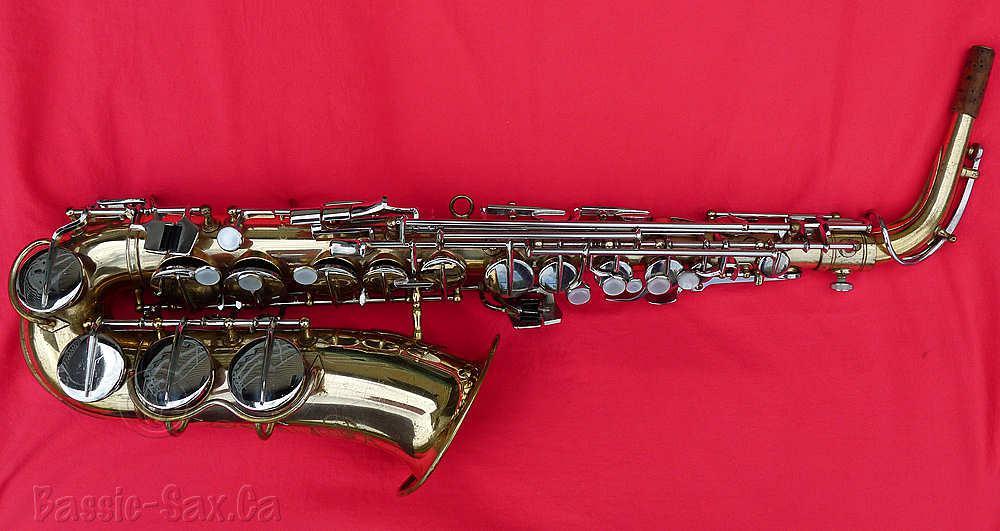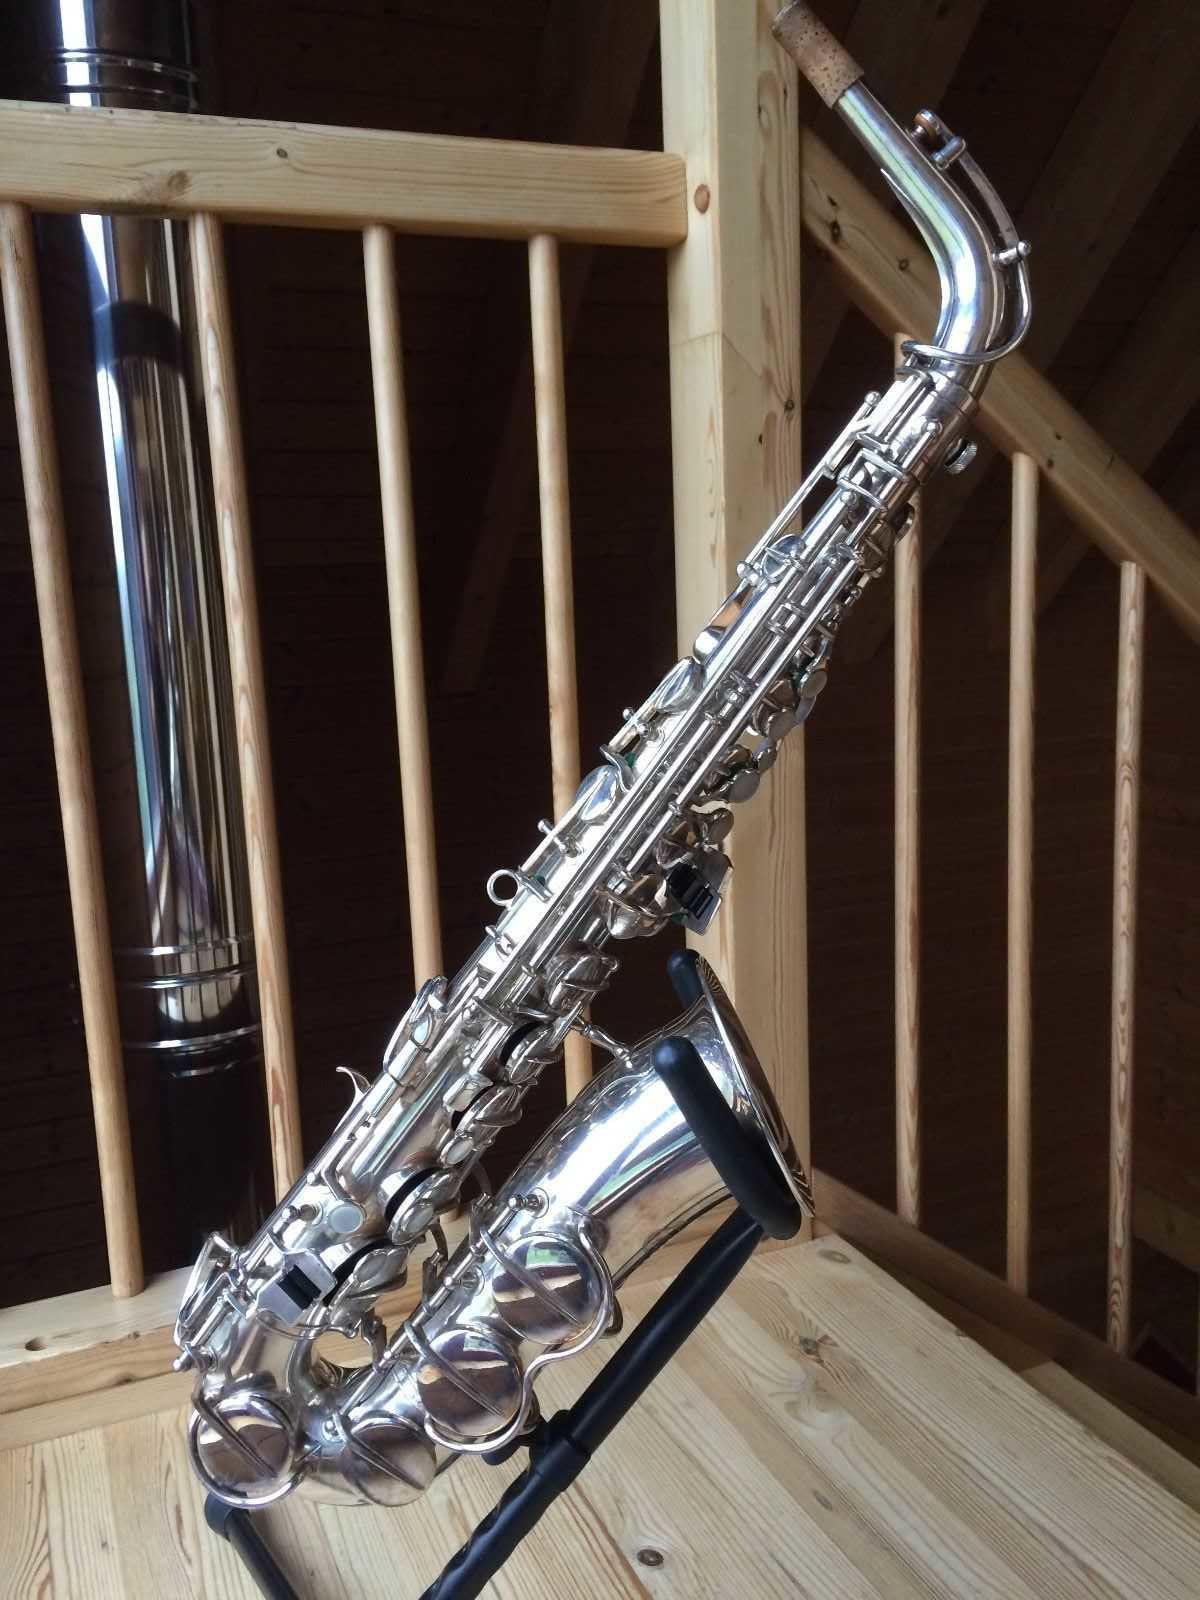The first image is the image on the left, the second image is the image on the right. Assess this claim about the two images: "A total of two saxophones are shown, and one saxophone is displayed on some type of red fabric.". Correct or not? Answer yes or no. Yes. The first image is the image on the left, the second image is the image on the right. Evaluate the accuracy of this statement regarding the images: "The left sax is gold and the right one is silver.". Is it true? Answer yes or no. Yes. 